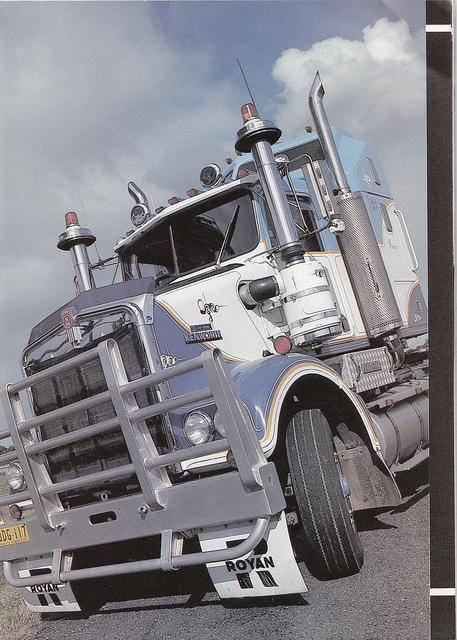How many exhaust pipes does the truck have?
Give a very brief answer. 2. 